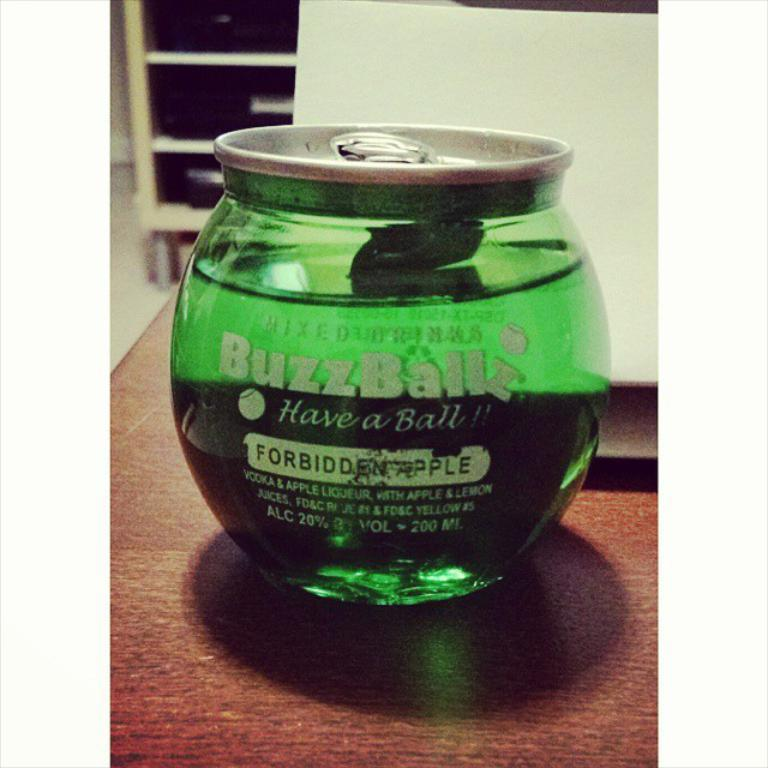<image>
Relay a brief, clear account of the picture shown. A product is labeled Forbidden Apple and colored green. 